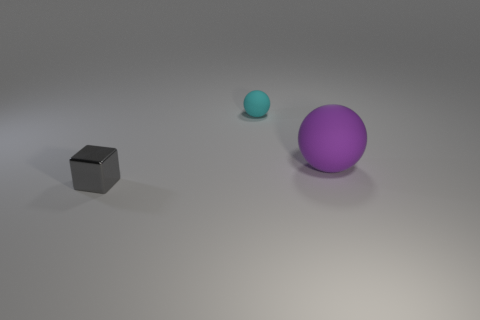What textures are visible on the objects in the image? The objects in the image appear to have a smooth texture with a matte finish. The light source creates a soft reflection, suggesting that the surfaces are not perfectly glossy but do have a slight sheen. 